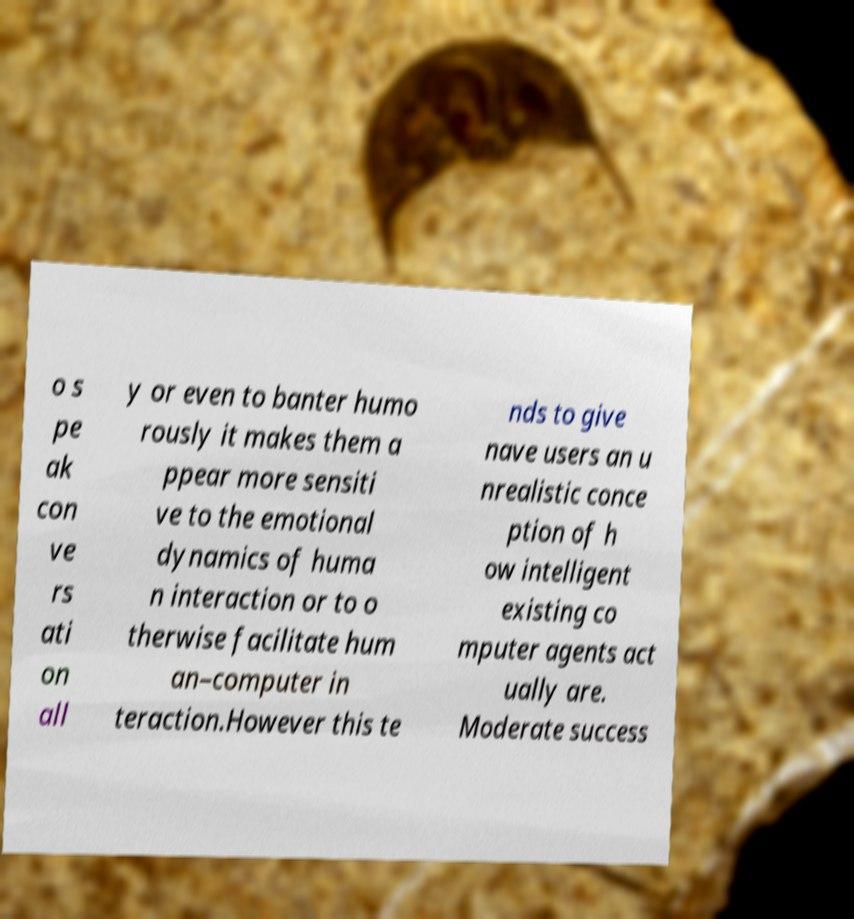I need the written content from this picture converted into text. Can you do that? o s pe ak con ve rs ati on all y or even to banter humo rously it makes them a ppear more sensiti ve to the emotional dynamics of huma n interaction or to o therwise facilitate hum an–computer in teraction.However this te nds to give nave users an u nrealistic conce ption of h ow intelligent existing co mputer agents act ually are. Moderate success 